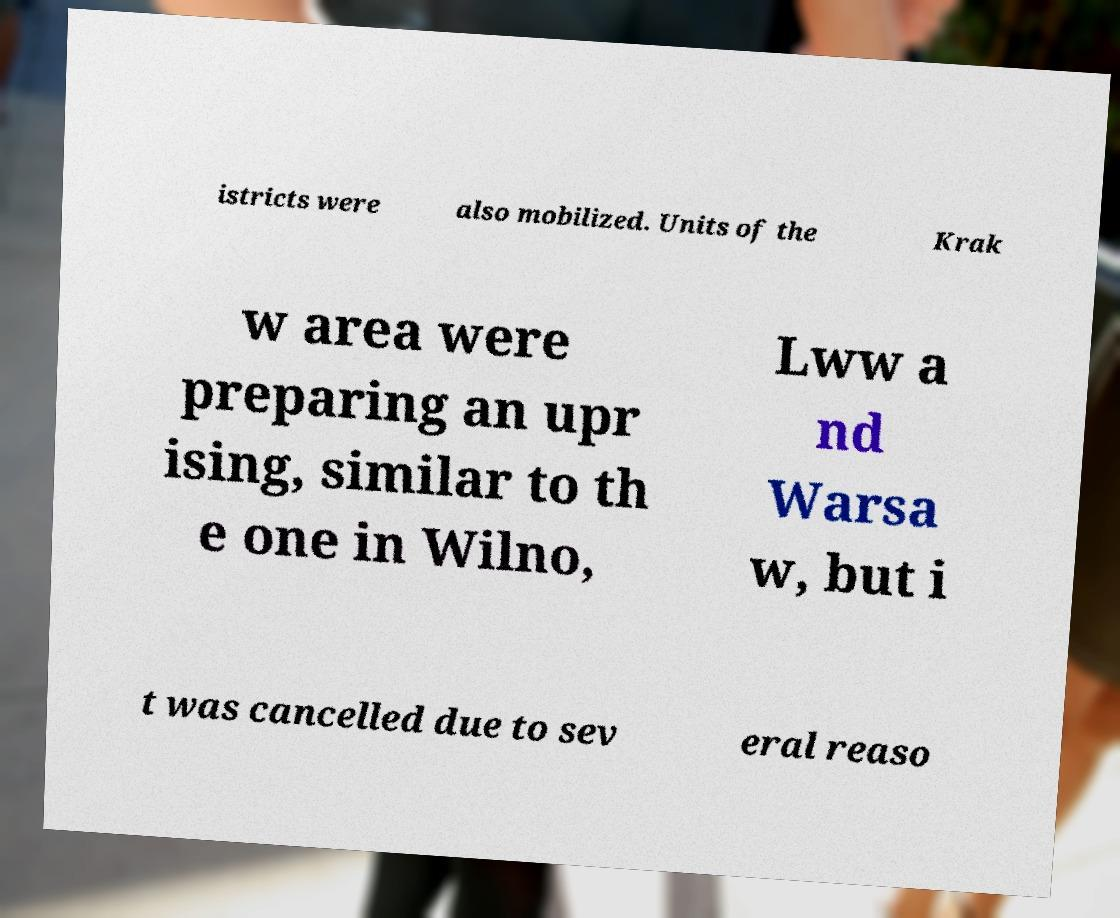What messages or text are displayed in this image? I need them in a readable, typed format. istricts were also mobilized. Units of the Krak w area were preparing an upr ising, similar to th e one in Wilno, Lww a nd Warsa w, but i t was cancelled due to sev eral reaso 